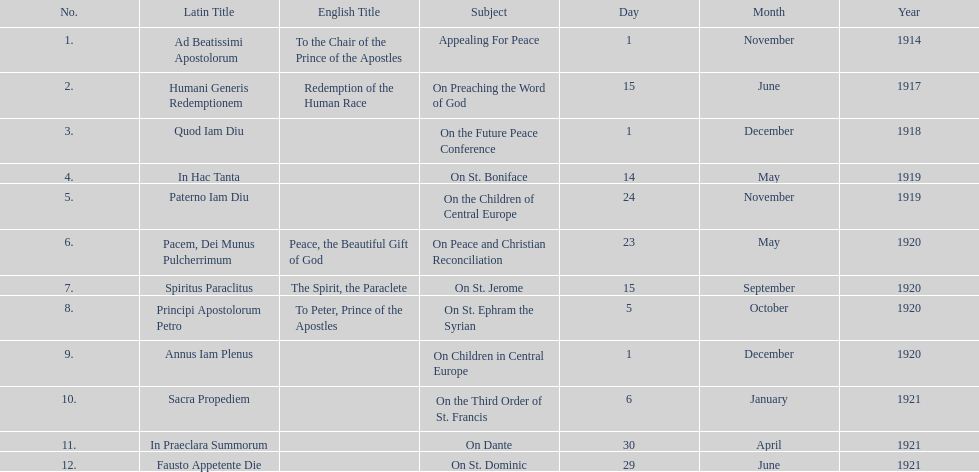What is the first english translation listed on the table? To the Chair of the Prince of the Apostles. 